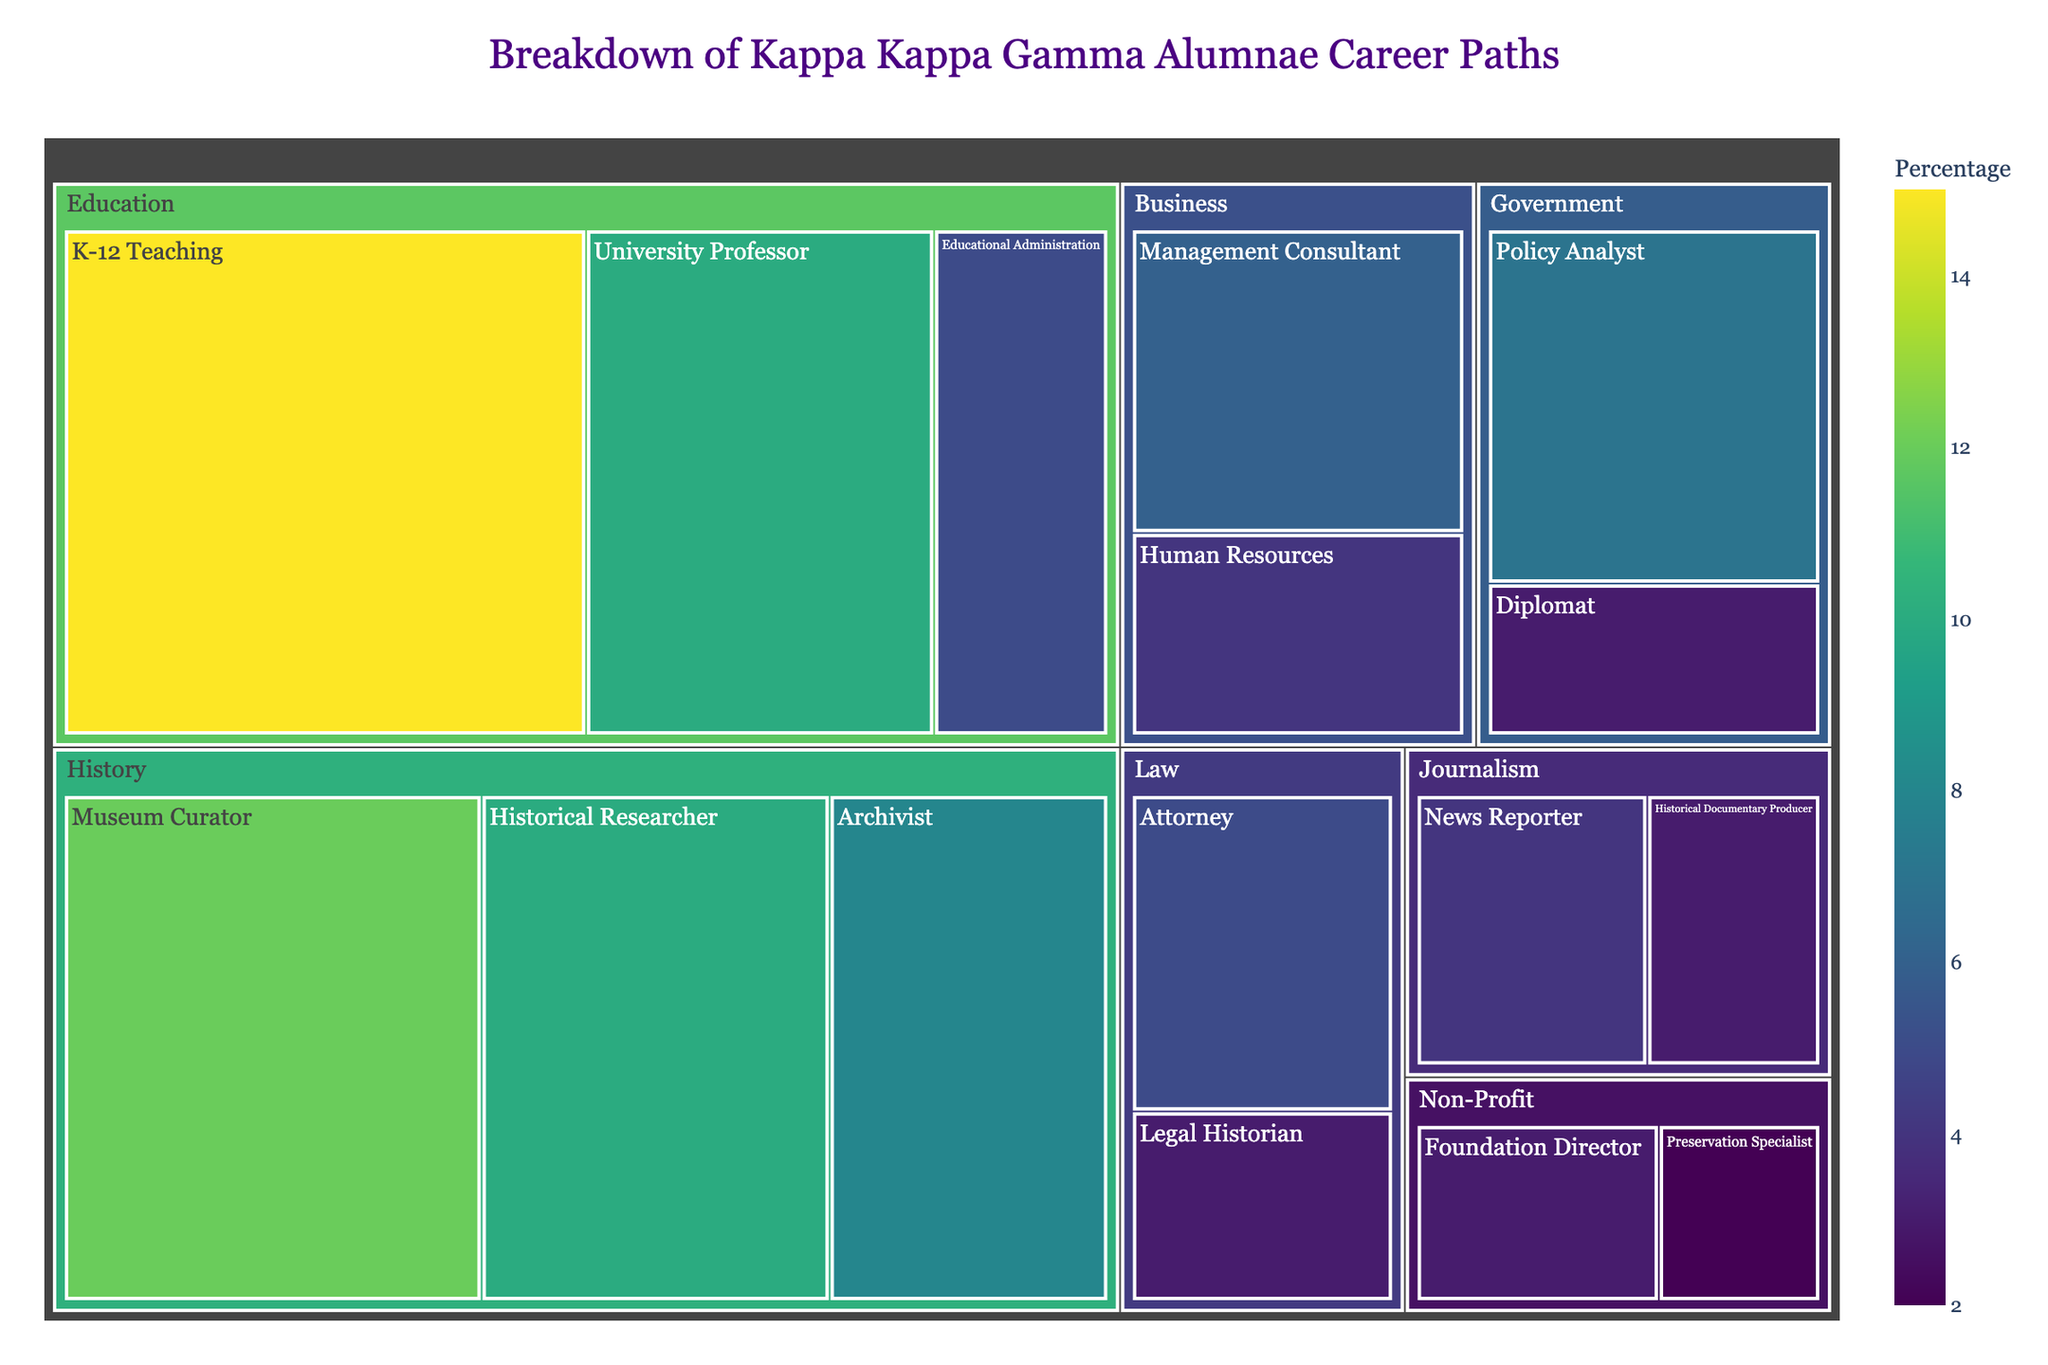What is the title of the Treemap? The title of the Treemap is displayed prominently at the top of the figure. It is "Breakdown of Kappa Kappa Gamma Alumnae Career Paths."
Answer: Breakdown of Kappa Kappa Gamma Alumnae Career Paths Which industry has the highest percentage of Kappa Kappa Gamma alumnae? By looking at the size of the sections in the Treemap, Education has the largest area which indicates it has the highest percentage.
Answer: Education What percentage of alumnae work in the History sector? The History section is divided into three subfields: Museum Curator (12%), Archivist (8%), and Historical Researcher (10%). Summing these up gives 12% + 8% + 10% = 30%.
Answer: 30% Which subfield within the Education industry employs the most alumnae? Within the Education industry, the subfields are K-12 Teaching (15%), University Professor (10%), and Educational Administration (5%). K-12 Teaching has the highest percentage at 15%.
Answer: K-12 Teaching Compare the total percentage of alumnae working in the Government and Business sectors. Which sector has more alumnae, and by how much? The Government sector has Policy Analyst (7%) and Diplomat (3%) which sums to 10%. The Business sector has Management Consultant (6%) and Human Resources (4%) summing to 10%. Both sectors have an equal percentage of 10%.
Answer: Both are equal, 10% What is the least common subfield for Kappa Kappa Gamma alumnae? By visually assessing the smallest sections in the Treemap, the Preservation Specialist subfield in the Non-Profit industry has the smallest percentage at 2%.
Answer: Preservation Specialist How does the percentage of alumnae in Journalism compare to those in Law? The Journalism sector includes News Reporter (4%) and Historical Documentary Producer (3%), totaling 7%. The Law sector includes Attorney (5%) and Legal Historian (3%), totaling 8%. Therefore, more alumnae work in Law than Journalism.
Answer: Law has 1% more What is the average percentage of alumnae working in the subfields of Non-Profit? The Non-Profit sector has Foundation Director (3%) and Preservation Specialist (2%). The average is (3% + 2%) / 2 = 2.5%.
Answer: 2.5% Is the percentage of alumnae working as University Professors higher than those working as Museum Curators? The percentage of alumnae working as University Professors is 10%, while those as Museum Curators is 12%. Therefore, it is lower.
Answer: No, it is lower Which has a greater percentage: Alumnae in Educational Administration or alumnae in Legal Historian? The percentage of alumnae in Educational Administration is 5%, whereas the percentage in Legal Historian is 3%. Educational Administration has a greater percentage.
Answer: Educational Administration 